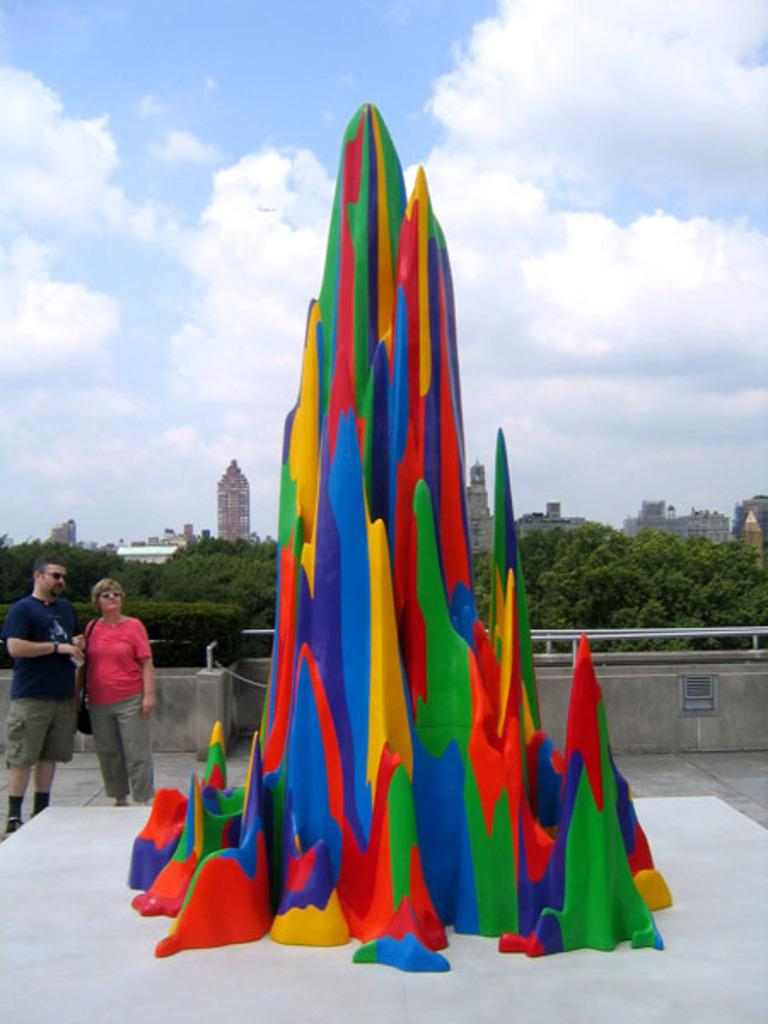What type of object is the main subject in the image? There is a multi-color statue in the image. Can you describe the people in the background? There are two persons standing in the background. What kind of vegetation is present in the image? There are trees with green color in the image. What type of structures can be seen in the image? There are buildings visible in the image. How would you describe the color of the sky in the image? The sky has a combination of white and blue colors. How many socks are hanging from the statue in the image? There are no socks present in the image; it features a multi-color statue with no visible socks. What is the weight of the icicle hanging from the statue in the image? There is no icicle present in the image; it features a multi-color statue with no visible icicles. 